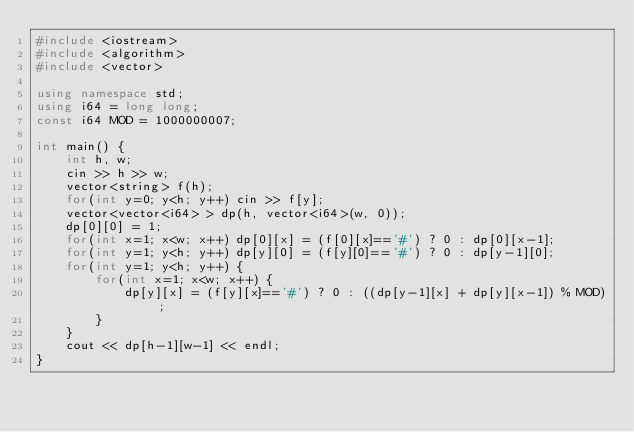Convert code to text. <code><loc_0><loc_0><loc_500><loc_500><_C++_>#include <iostream>
#include <algorithm>
#include <vector>

using namespace std;
using i64 = long long;
const i64 MOD = 1000000007;

int main() {
    int h, w;
    cin >> h >> w;
    vector<string> f(h);
    for(int y=0; y<h; y++) cin >> f[y];
    vector<vector<i64> > dp(h, vector<i64>(w, 0));
    dp[0][0] = 1;
    for(int x=1; x<w; x++) dp[0][x] = (f[0][x]=='#') ? 0 : dp[0][x-1];
    for(int y=1; y<h; y++) dp[y][0] = (f[y][0]=='#') ? 0 : dp[y-1][0];
    for(int y=1; y<h; y++) {
        for(int x=1; x<w; x++) {
            dp[y][x] = (f[y][x]=='#') ? 0 : ((dp[y-1][x] + dp[y][x-1]) % MOD);
        }
    }
    cout << dp[h-1][w-1] << endl;
}</code> 